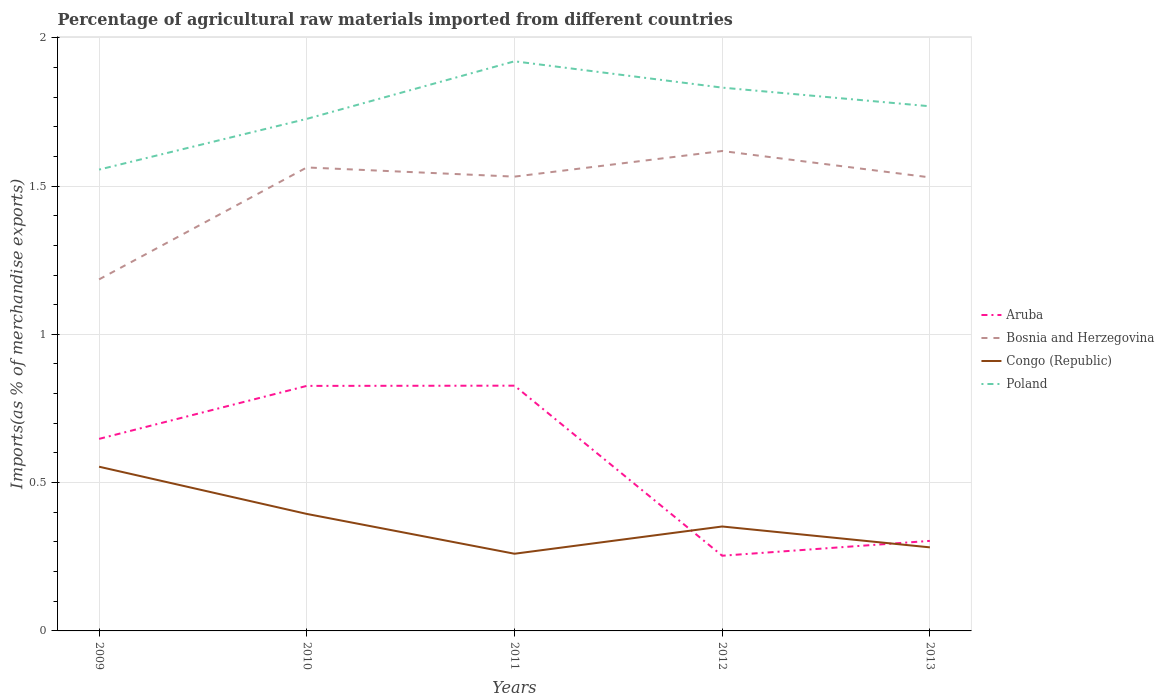How many different coloured lines are there?
Offer a very short reply. 4. Does the line corresponding to Aruba intersect with the line corresponding to Bosnia and Herzegovina?
Your answer should be very brief. No. Is the number of lines equal to the number of legend labels?
Your answer should be very brief. Yes. Across all years, what is the maximum percentage of imports to different countries in Poland?
Provide a short and direct response. 1.56. What is the total percentage of imports to different countries in Poland in the graph?
Your response must be concise. 0.15. What is the difference between the highest and the second highest percentage of imports to different countries in Bosnia and Herzegovina?
Make the answer very short. 0.43. How many lines are there?
Your response must be concise. 4. How many years are there in the graph?
Ensure brevity in your answer.  5. Are the values on the major ticks of Y-axis written in scientific E-notation?
Your answer should be compact. No. Does the graph contain grids?
Give a very brief answer. Yes. How are the legend labels stacked?
Make the answer very short. Vertical. What is the title of the graph?
Your answer should be very brief. Percentage of agricultural raw materials imported from different countries. Does "Arab World" appear as one of the legend labels in the graph?
Your response must be concise. No. What is the label or title of the Y-axis?
Ensure brevity in your answer.  Imports(as % of merchandise exports). What is the Imports(as % of merchandise exports) of Aruba in 2009?
Offer a very short reply. 0.65. What is the Imports(as % of merchandise exports) in Bosnia and Herzegovina in 2009?
Offer a very short reply. 1.19. What is the Imports(as % of merchandise exports) in Congo (Republic) in 2009?
Your answer should be compact. 0.55. What is the Imports(as % of merchandise exports) of Poland in 2009?
Your answer should be compact. 1.56. What is the Imports(as % of merchandise exports) of Aruba in 2010?
Your answer should be very brief. 0.83. What is the Imports(as % of merchandise exports) of Bosnia and Herzegovina in 2010?
Your response must be concise. 1.56. What is the Imports(as % of merchandise exports) in Congo (Republic) in 2010?
Make the answer very short. 0.39. What is the Imports(as % of merchandise exports) in Poland in 2010?
Give a very brief answer. 1.73. What is the Imports(as % of merchandise exports) of Aruba in 2011?
Your response must be concise. 0.83. What is the Imports(as % of merchandise exports) in Bosnia and Herzegovina in 2011?
Offer a very short reply. 1.53. What is the Imports(as % of merchandise exports) in Congo (Republic) in 2011?
Offer a very short reply. 0.26. What is the Imports(as % of merchandise exports) of Poland in 2011?
Offer a terse response. 1.92. What is the Imports(as % of merchandise exports) in Aruba in 2012?
Offer a very short reply. 0.25. What is the Imports(as % of merchandise exports) in Bosnia and Herzegovina in 2012?
Provide a short and direct response. 1.62. What is the Imports(as % of merchandise exports) of Congo (Republic) in 2012?
Provide a short and direct response. 0.35. What is the Imports(as % of merchandise exports) of Poland in 2012?
Give a very brief answer. 1.83. What is the Imports(as % of merchandise exports) of Aruba in 2013?
Provide a succinct answer. 0.3. What is the Imports(as % of merchandise exports) in Bosnia and Herzegovina in 2013?
Your response must be concise. 1.53. What is the Imports(as % of merchandise exports) of Congo (Republic) in 2013?
Your answer should be very brief. 0.28. What is the Imports(as % of merchandise exports) of Poland in 2013?
Ensure brevity in your answer.  1.77. Across all years, what is the maximum Imports(as % of merchandise exports) of Aruba?
Make the answer very short. 0.83. Across all years, what is the maximum Imports(as % of merchandise exports) in Bosnia and Herzegovina?
Your answer should be very brief. 1.62. Across all years, what is the maximum Imports(as % of merchandise exports) in Congo (Republic)?
Offer a terse response. 0.55. Across all years, what is the maximum Imports(as % of merchandise exports) in Poland?
Offer a very short reply. 1.92. Across all years, what is the minimum Imports(as % of merchandise exports) of Aruba?
Provide a succinct answer. 0.25. Across all years, what is the minimum Imports(as % of merchandise exports) of Bosnia and Herzegovina?
Provide a succinct answer. 1.19. Across all years, what is the minimum Imports(as % of merchandise exports) in Congo (Republic)?
Provide a short and direct response. 0.26. Across all years, what is the minimum Imports(as % of merchandise exports) of Poland?
Keep it short and to the point. 1.56. What is the total Imports(as % of merchandise exports) of Aruba in the graph?
Ensure brevity in your answer.  2.86. What is the total Imports(as % of merchandise exports) in Bosnia and Herzegovina in the graph?
Make the answer very short. 7.43. What is the total Imports(as % of merchandise exports) of Congo (Republic) in the graph?
Offer a terse response. 1.84. What is the total Imports(as % of merchandise exports) of Poland in the graph?
Offer a very short reply. 8.8. What is the difference between the Imports(as % of merchandise exports) of Aruba in 2009 and that in 2010?
Your answer should be very brief. -0.18. What is the difference between the Imports(as % of merchandise exports) in Bosnia and Herzegovina in 2009 and that in 2010?
Ensure brevity in your answer.  -0.38. What is the difference between the Imports(as % of merchandise exports) of Congo (Republic) in 2009 and that in 2010?
Your response must be concise. 0.16. What is the difference between the Imports(as % of merchandise exports) of Poland in 2009 and that in 2010?
Make the answer very short. -0.17. What is the difference between the Imports(as % of merchandise exports) of Aruba in 2009 and that in 2011?
Keep it short and to the point. -0.18. What is the difference between the Imports(as % of merchandise exports) in Bosnia and Herzegovina in 2009 and that in 2011?
Offer a very short reply. -0.35. What is the difference between the Imports(as % of merchandise exports) of Congo (Republic) in 2009 and that in 2011?
Make the answer very short. 0.29. What is the difference between the Imports(as % of merchandise exports) of Poland in 2009 and that in 2011?
Ensure brevity in your answer.  -0.37. What is the difference between the Imports(as % of merchandise exports) of Aruba in 2009 and that in 2012?
Offer a terse response. 0.39. What is the difference between the Imports(as % of merchandise exports) of Bosnia and Herzegovina in 2009 and that in 2012?
Your response must be concise. -0.43. What is the difference between the Imports(as % of merchandise exports) in Congo (Republic) in 2009 and that in 2012?
Give a very brief answer. 0.2. What is the difference between the Imports(as % of merchandise exports) in Poland in 2009 and that in 2012?
Offer a very short reply. -0.28. What is the difference between the Imports(as % of merchandise exports) in Aruba in 2009 and that in 2013?
Your answer should be very brief. 0.34. What is the difference between the Imports(as % of merchandise exports) in Bosnia and Herzegovina in 2009 and that in 2013?
Keep it short and to the point. -0.34. What is the difference between the Imports(as % of merchandise exports) of Congo (Republic) in 2009 and that in 2013?
Provide a succinct answer. 0.27. What is the difference between the Imports(as % of merchandise exports) in Poland in 2009 and that in 2013?
Offer a terse response. -0.21. What is the difference between the Imports(as % of merchandise exports) in Aruba in 2010 and that in 2011?
Give a very brief answer. -0. What is the difference between the Imports(as % of merchandise exports) in Bosnia and Herzegovina in 2010 and that in 2011?
Provide a succinct answer. 0.03. What is the difference between the Imports(as % of merchandise exports) in Congo (Republic) in 2010 and that in 2011?
Offer a terse response. 0.13. What is the difference between the Imports(as % of merchandise exports) of Poland in 2010 and that in 2011?
Keep it short and to the point. -0.19. What is the difference between the Imports(as % of merchandise exports) of Aruba in 2010 and that in 2012?
Provide a succinct answer. 0.57. What is the difference between the Imports(as % of merchandise exports) of Bosnia and Herzegovina in 2010 and that in 2012?
Ensure brevity in your answer.  -0.06. What is the difference between the Imports(as % of merchandise exports) in Congo (Republic) in 2010 and that in 2012?
Your answer should be compact. 0.04. What is the difference between the Imports(as % of merchandise exports) of Poland in 2010 and that in 2012?
Your answer should be very brief. -0.11. What is the difference between the Imports(as % of merchandise exports) in Aruba in 2010 and that in 2013?
Offer a very short reply. 0.52. What is the difference between the Imports(as % of merchandise exports) in Bosnia and Herzegovina in 2010 and that in 2013?
Keep it short and to the point. 0.03. What is the difference between the Imports(as % of merchandise exports) in Congo (Republic) in 2010 and that in 2013?
Your answer should be very brief. 0.11. What is the difference between the Imports(as % of merchandise exports) in Poland in 2010 and that in 2013?
Your answer should be compact. -0.04. What is the difference between the Imports(as % of merchandise exports) in Aruba in 2011 and that in 2012?
Give a very brief answer. 0.57. What is the difference between the Imports(as % of merchandise exports) in Bosnia and Herzegovina in 2011 and that in 2012?
Offer a terse response. -0.09. What is the difference between the Imports(as % of merchandise exports) of Congo (Republic) in 2011 and that in 2012?
Your answer should be very brief. -0.09. What is the difference between the Imports(as % of merchandise exports) in Poland in 2011 and that in 2012?
Your answer should be compact. 0.09. What is the difference between the Imports(as % of merchandise exports) in Aruba in 2011 and that in 2013?
Make the answer very short. 0.52. What is the difference between the Imports(as % of merchandise exports) in Bosnia and Herzegovina in 2011 and that in 2013?
Provide a succinct answer. 0. What is the difference between the Imports(as % of merchandise exports) in Congo (Republic) in 2011 and that in 2013?
Provide a short and direct response. -0.02. What is the difference between the Imports(as % of merchandise exports) in Poland in 2011 and that in 2013?
Offer a terse response. 0.15. What is the difference between the Imports(as % of merchandise exports) in Aruba in 2012 and that in 2013?
Keep it short and to the point. -0.05. What is the difference between the Imports(as % of merchandise exports) of Bosnia and Herzegovina in 2012 and that in 2013?
Ensure brevity in your answer.  0.09. What is the difference between the Imports(as % of merchandise exports) in Congo (Republic) in 2012 and that in 2013?
Give a very brief answer. 0.07. What is the difference between the Imports(as % of merchandise exports) in Poland in 2012 and that in 2013?
Provide a succinct answer. 0.06. What is the difference between the Imports(as % of merchandise exports) of Aruba in 2009 and the Imports(as % of merchandise exports) of Bosnia and Herzegovina in 2010?
Offer a very short reply. -0.92. What is the difference between the Imports(as % of merchandise exports) in Aruba in 2009 and the Imports(as % of merchandise exports) in Congo (Republic) in 2010?
Provide a succinct answer. 0.25. What is the difference between the Imports(as % of merchandise exports) of Aruba in 2009 and the Imports(as % of merchandise exports) of Poland in 2010?
Offer a terse response. -1.08. What is the difference between the Imports(as % of merchandise exports) of Bosnia and Herzegovina in 2009 and the Imports(as % of merchandise exports) of Congo (Republic) in 2010?
Provide a short and direct response. 0.79. What is the difference between the Imports(as % of merchandise exports) in Bosnia and Herzegovina in 2009 and the Imports(as % of merchandise exports) in Poland in 2010?
Offer a terse response. -0.54. What is the difference between the Imports(as % of merchandise exports) of Congo (Republic) in 2009 and the Imports(as % of merchandise exports) of Poland in 2010?
Your answer should be compact. -1.17. What is the difference between the Imports(as % of merchandise exports) in Aruba in 2009 and the Imports(as % of merchandise exports) in Bosnia and Herzegovina in 2011?
Provide a succinct answer. -0.88. What is the difference between the Imports(as % of merchandise exports) in Aruba in 2009 and the Imports(as % of merchandise exports) in Congo (Republic) in 2011?
Provide a short and direct response. 0.39. What is the difference between the Imports(as % of merchandise exports) of Aruba in 2009 and the Imports(as % of merchandise exports) of Poland in 2011?
Keep it short and to the point. -1.27. What is the difference between the Imports(as % of merchandise exports) of Bosnia and Herzegovina in 2009 and the Imports(as % of merchandise exports) of Congo (Republic) in 2011?
Offer a terse response. 0.93. What is the difference between the Imports(as % of merchandise exports) in Bosnia and Herzegovina in 2009 and the Imports(as % of merchandise exports) in Poland in 2011?
Keep it short and to the point. -0.74. What is the difference between the Imports(as % of merchandise exports) in Congo (Republic) in 2009 and the Imports(as % of merchandise exports) in Poland in 2011?
Provide a short and direct response. -1.37. What is the difference between the Imports(as % of merchandise exports) of Aruba in 2009 and the Imports(as % of merchandise exports) of Bosnia and Herzegovina in 2012?
Offer a terse response. -0.97. What is the difference between the Imports(as % of merchandise exports) of Aruba in 2009 and the Imports(as % of merchandise exports) of Congo (Republic) in 2012?
Offer a terse response. 0.3. What is the difference between the Imports(as % of merchandise exports) in Aruba in 2009 and the Imports(as % of merchandise exports) in Poland in 2012?
Your answer should be compact. -1.18. What is the difference between the Imports(as % of merchandise exports) of Bosnia and Herzegovina in 2009 and the Imports(as % of merchandise exports) of Congo (Republic) in 2012?
Make the answer very short. 0.83. What is the difference between the Imports(as % of merchandise exports) of Bosnia and Herzegovina in 2009 and the Imports(as % of merchandise exports) of Poland in 2012?
Make the answer very short. -0.65. What is the difference between the Imports(as % of merchandise exports) in Congo (Republic) in 2009 and the Imports(as % of merchandise exports) in Poland in 2012?
Offer a very short reply. -1.28. What is the difference between the Imports(as % of merchandise exports) of Aruba in 2009 and the Imports(as % of merchandise exports) of Bosnia and Herzegovina in 2013?
Your answer should be compact. -0.88. What is the difference between the Imports(as % of merchandise exports) of Aruba in 2009 and the Imports(as % of merchandise exports) of Congo (Republic) in 2013?
Provide a succinct answer. 0.37. What is the difference between the Imports(as % of merchandise exports) in Aruba in 2009 and the Imports(as % of merchandise exports) in Poland in 2013?
Keep it short and to the point. -1.12. What is the difference between the Imports(as % of merchandise exports) of Bosnia and Herzegovina in 2009 and the Imports(as % of merchandise exports) of Congo (Republic) in 2013?
Your answer should be very brief. 0.9. What is the difference between the Imports(as % of merchandise exports) in Bosnia and Herzegovina in 2009 and the Imports(as % of merchandise exports) in Poland in 2013?
Your response must be concise. -0.58. What is the difference between the Imports(as % of merchandise exports) of Congo (Republic) in 2009 and the Imports(as % of merchandise exports) of Poland in 2013?
Keep it short and to the point. -1.22. What is the difference between the Imports(as % of merchandise exports) in Aruba in 2010 and the Imports(as % of merchandise exports) in Bosnia and Herzegovina in 2011?
Your answer should be compact. -0.71. What is the difference between the Imports(as % of merchandise exports) in Aruba in 2010 and the Imports(as % of merchandise exports) in Congo (Republic) in 2011?
Your answer should be very brief. 0.57. What is the difference between the Imports(as % of merchandise exports) of Aruba in 2010 and the Imports(as % of merchandise exports) of Poland in 2011?
Your answer should be compact. -1.09. What is the difference between the Imports(as % of merchandise exports) in Bosnia and Herzegovina in 2010 and the Imports(as % of merchandise exports) in Congo (Republic) in 2011?
Make the answer very short. 1.3. What is the difference between the Imports(as % of merchandise exports) in Bosnia and Herzegovina in 2010 and the Imports(as % of merchandise exports) in Poland in 2011?
Your response must be concise. -0.36. What is the difference between the Imports(as % of merchandise exports) in Congo (Republic) in 2010 and the Imports(as % of merchandise exports) in Poland in 2011?
Provide a short and direct response. -1.53. What is the difference between the Imports(as % of merchandise exports) of Aruba in 2010 and the Imports(as % of merchandise exports) of Bosnia and Herzegovina in 2012?
Offer a very short reply. -0.79. What is the difference between the Imports(as % of merchandise exports) in Aruba in 2010 and the Imports(as % of merchandise exports) in Congo (Republic) in 2012?
Your response must be concise. 0.47. What is the difference between the Imports(as % of merchandise exports) in Aruba in 2010 and the Imports(as % of merchandise exports) in Poland in 2012?
Your answer should be very brief. -1.01. What is the difference between the Imports(as % of merchandise exports) of Bosnia and Herzegovina in 2010 and the Imports(as % of merchandise exports) of Congo (Republic) in 2012?
Provide a short and direct response. 1.21. What is the difference between the Imports(as % of merchandise exports) of Bosnia and Herzegovina in 2010 and the Imports(as % of merchandise exports) of Poland in 2012?
Make the answer very short. -0.27. What is the difference between the Imports(as % of merchandise exports) in Congo (Republic) in 2010 and the Imports(as % of merchandise exports) in Poland in 2012?
Give a very brief answer. -1.44. What is the difference between the Imports(as % of merchandise exports) in Aruba in 2010 and the Imports(as % of merchandise exports) in Bosnia and Herzegovina in 2013?
Make the answer very short. -0.7. What is the difference between the Imports(as % of merchandise exports) in Aruba in 2010 and the Imports(as % of merchandise exports) in Congo (Republic) in 2013?
Keep it short and to the point. 0.54. What is the difference between the Imports(as % of merchandise exports) in Aruba in 2010 and the Imports(as % of merchandise exports) in Poland in 2013?
Your answer should be very brief. -0.94. What is the difference between the Imports(as % of merchandise exports) in Bosnia and Herzegovina in 2010 and the Imports(as % of merchandise exports) in Congo (Republic) in 2013?
Make the answer very short. 1.28. What is the difference between the Imports(as % of merchandise exports) in Bosnia and Herzegovina in 2010 and the Imports(as % of merchandise exports) in Poland in 2013?
Give a very brief answer. -0.21. What is the difference between the Imports(as % of merchandise exports) of Congo (Republic) in 2010 and the Imports(as % of merchandise exports) of Poland in 2013?
Your answer should be compact. -1.37. What is the difference between the Imports(as % of merchandise exports) of Aruba in 2011 and the Imports(as % of merchandise exports) of Bosnia and Herzegovina in 2012?
Your answer should be compact. -0.79. What is the difference between the Imports(as % of merchandise exports) of Aruba in 2011 and the Imports(as % of merchandise exports) of Congo (Republic) in 2012?
Make the answer very short. 0.47. What is the difference between the Imports(as % of merchandise exports) in Aruba in 2011 and the Imports(as % of merchandise exports) in Poland in 2012?
Give a very brief answer. -1. What is the difference between the Imports(as % of merchandise exports) of Bosnia and Herzegovina in 2011 and the Imports(as % of merchandise exports) of Congo (Republic) in 2012?
Your response must be concise. 1.18. What is the difference between the Imports(as % of merchandise exports) of Bosnia and Herzegovina in 2011 and the Imports(as % of merchandise exports) of Poland in 2012?
Offer a terse response. -0.3. What is the difference between the Imports(as % of merchandise exports) in Congo (Republic) in 2011 and the Imports(as % of merchandise exports) in Poland in 2012?
Give a very brief answer. -1.57. What is the difference between the Imports(as % of merchandise exports) in Aruba in 2011 and the Imports(as % of merchandise exports) in Bosnia and Herzegovina in 2013?
Offer a very short reply. -0.7. What is the difference between the Imports(as % of merchandise exports) in Aruba in 2011 and the Imports(as % of merchandise exports) in Congo (Republic) in 2013?
Your answer should be compact. 0.55. What is the difference between the Imports(as % of merchandise exports) in Aruba in 2011 and the Imports(as % of merchandise exports) in Poland in 2013?
Offer a terse response. -0.94. What is the difference between the Imports(as % of merchandise exports) in Bosnia and Herzegovina in 2011 and the Imports(as % of merchandise exports) in Poland in 2013?
Provide a succinct answer. -0.24. What is the difference between the Imports(as % of merchandise exports) of Congo (Republic) in 2011 and the Imports(as % of merchandise exports) of Poland in 2013?
Offer a terse response. -1.51. What is the difference between the Imports(as % of merchandise exports) in Aruba in 2012 and the Imports(as % of merchandise exports) in Bosnia and Herzegovina in 2013?
Provide a succinct answer. -1.28. What is the difference between the Imports(as % of merchandise exports) of Aruba in 2012 and the Imports(as % of merchandise exports) of Congo (Republic) in 2013?
Make the answer very short. -0.03. What is the difference between the Imports(as % of merchandise exports) in Aruba in 2012 and the Imports(as % of merchandise exports) in Poland in 2013?
Offer a very short reply. -1.52. What is the difference between the Imports(as % of merchandise exports) of Bosnia and Herzegovina in 2012 and the Imports(as % of merchandise exports) of Congo (Republic) in 2013?
Your response must be concise. 1.34. What is the difference between the Imports(as % of merchandise exports) of Bosnia and Herzegovina in 2012 and the Imports(as % of merchandise exports) of Poland in 2013?
Ensure brevity in your answer.  -0.15. What is the difference between the Imports(as % of merchandise exports) of Congo (Republic) in 2012 and the Imports(as % of merchandise exports) of Poland in 2013?
Your response must be concise. -1.42. What is the average Imports(as % of merchandise exports) in Aruba per year?
Keep it short and to the point. 0.57. What is the average Imports(as % of merchandise exports) in Bosnia and Herzegovina per year?
Provide a short and direct response. 1.49. What is the average Imports(as % of merchandise exports) in Congo (Republic) per year?
Your answer should be compact. 0.37. What is the average Imports(as % of merchandise exports) of Poland per year?
Your answer should be very brief. 1.76. In the year 2009, what is the difference between the Imports(as % of merchandise exports) of Aruba and Imports(as % of merchandise exports) of Bosnia and Herzegovina?
Keep it short and to the point. -0.54. In the year 2009, what is the difference between the Imports(as % of merchandise exports) in Aruba and Imports(as % of merchandise exports) in Congo (Republic)?
Ensure brevity in your answer.  0.09. In the year 2009, what is the difference between the Imports(as % of merchandise exports) of Aruba and Imports(as % of merchandise exports) of Poland?
Your answer should be compact. -0.91. In the year 2009, what is the difference between the Imports(as % of merchandise exports) in Bosnia and Herzegovina and Imports(as % of merchandise exports) in Congo (Republic)?
Keep it short and to the point. 0.63. In the year 2009, what is the difference between the Imports(as % of merchandise exports) in Bosnia and Herzegovina and Imports(as % of merchandise exports) in Poland?
Your response must be concise. -0.37. In the year 2009, what is the difference between the Imports(as % of merchandise exports) of Congo (Republic) and Imports(as % of merchandise exports) of Poland?
Offer a very short reply. -1. In the year 2010, what is the difference between the Imports(as % of merchandise exports) of Aruba and Imports(as % of merchandise exports) of Bosnia and Herzegovina?
Offer a very short reply. -0.74. In the year 2010, what is the difference between the Imports(as % of merchandise exports) in Aruba and Imports(as % of merchandise exports) in Congo (Republic)?
Give a very brief answer. 0.43. In the year 2010, what is the difference between the Imports(as % of merchandise exports) in Aruba and Imports(as % of merchandise exports) in Poland?
Offer a very short reply. -0.9. In the year 2010, what is the difference between the Imports(as % of merchandise exports) of Bosnia and Herzegovina and Imports(as % of merchandise exports) of Congo (Republic)?
Give a very brief answer. 1.17. In the year 2010, what is the difference between the Imports(as % of merchandise exports) in Bosnia and Herzegovina and Imports(as % of merchandise exports) in Poland?
Your response must be concise. -0.16. In the year 2010, what is the difference between the Imports(as % of merchandise exports) of Congo (Republic) and Imports(as % of merchandise exports) of Poland?
Ensure brevity in your answer.  -1.33. In the year 2011, what is the difference between the Imports(as % of merchandise exports) of Aruba and Imports(as % of merchandise exports) of Bosnia and Herzegovina?
Keep it short and to the point. -0.7. In the year 2011, what is the difference between the Imports(as % of merchandise exports) in Aruba and Imports(as % of merchandise exports) in Congo (Republic)?
Ensure brevity in your answer.  0.57. In the year 2011, what is the difference between the Imports(as % of merchandise exports) in Aruba and Imports(as % of merchandise exports) in Poland?
Make the answer very short. -1.09. In the year 2011, what is the difference between the Imports(as % of merchandise exports) of Bosnia and Herzegovina and Imports(as % of merchandise exports) of Congo (Republic)?
Provide a short and direct response. 1.27. In the year 2011, what is the difference between the Imports(as % of merchandise exports) in Bosnia and Herzegovina and Imports(as % of merchandise exports) in Poland?
Provide a short and direct response. -0.39. In the year 2011, what is the difference between the Imports(as % of merchandise exports) of Congo (Republic) and Imports(as % of merchandise exports) of Poland?
Your response must be concise. -1.66. In the year 2012, what is the difference between the Imports(as % of merchandise exports) of Aruba and Imports(as % of merchandise exports) of Bosnia and Herzegovina?
Provide a succinct answer. -1.36. In the year 2012, what is the difference between the Imports(as % of merchandise exports) of Aruba and Imports(as % of merchandise exports) of Congo (Republic)?
Make the answer very short. -0.1. In the year 2012, what is the difference between the Imports(as % of merchandise exports) in Aruba and Imports(as % of merchandise exports) in Poland?
Your answer should be very brief. -1.58. In the year 2012, what is the difference between the Imports(as % of merchandise exports) of Bosnia and Herzegovina and Imports(as % of merchandise exports) of Congo (Republic)?
Offer a very short reply. 1.27. In the year 2012, what is the difference between the Imports(as % of merchandise exports) in Bosnia and Herzegovina and Imports(as % of merchandise exports) in Poland?
Offer a very short reply. -0.21. In the year 2012, what is the difference between the Imports(as % of merchandise exports) of Congo (Republic) and Imports(as % of merchandise exports) of Poland?
Offer a terse response. -1.48. In the year 2013, what is the difference between the Imports(as % of merchandise exports) of Aruba and Imports(as % of merchandise exports) of Bosnia and Herzegovina?
Offer a terse response. -1.23. In the year 2013, what is the difference between the Imports(as % of merchandise exports) of Aruba and Imports(as % of merchandise exports) of Congo (Republic)?
Offer a very short reply. 0.02. In the year 2013, what is the difference between the Imports(as % of merchandise exports) of Aruba and Imports(as % of merchandise exports) of Poland?
Your answer should be compact. -1.47. In the year 2013, what is the difference between the Imports(as % of merchandise exports) in Bosnia and Herzegovina and Imports(as % of merchandise exports) in Congo (Republic)?
Ensure brevity in your answer.  1.25. In the year 2013, what is the difference between the Imports(as % of merchandise exports) in Bosnia and Herzegovina and Imports(as % of merchandise exports) in Poland?
Provide a succinct answer. -0.24. In the year 2013, what is the difference between the Imports(as % of merchandise exports) in Congo (Republic) and Imports(as % of merchandise exports) in Poland?
Provide a short and direct response. -1.49. What is the ratio of the Imports(as % of merchandise exports) in Aruba in 2009 to that in 2010?
Your response must be concise. 0.78. What is the ratio of the Imports(as % of merchandise exports) of Bosnia and Herzegovina in 2009 to that in 2010?
Offer a terse response. 0.76. What is the ratio of the Imports(as % of merchandise exports) of Congo (Republic) in 2009 to that in 2010?
Keep it short and to the point. 1.4. What is the ratio of the Imports(as % of merchandise exports) in Poland in 2009 to that in 2010?
Your answer should be compact. 0.9. What is the ratio of the Imports(as % of merchandise exports) in Aruba in 2009 to that in 2011?
Give a very brief answer. 0.78. What is the ratio of the Imports(as % of merchandise exports) of Bosnia and Herzegovina in 2009 to that in 2011?
Your answer should be compact. 0.77. What is the ratio of the Imports(as % of merchandise exports) of Congo (Republic) in 2009 to that in 2011?
Make the answer very short. 2.13. What is the ratio of the Imports(as % of merchandise exports) of Poland in 2009 to that in 2011?
Give a very brief answer. 0.81. What is the ratio of the Imports(as % of merchandise exports) in Aruba in 2009 to that in 2012?
Offer a terse response. 2.55. What is the ratio of the Imports(as % of merchandise exports) of Bosnia and Herzegovina in 2009 to that in 2012?
Ensure brevity in your answer.  0.73. What is the ratio of the Imports(as % of merchandise exports) in Congo (Republic) in 2009 to that in 2012?
Provide a short and direct response. 1.57. What is the ratio of the Imports(as % of merchandise exports) of Poland in 2009 to that in 2012?
Provide a succinct answer. 0.85. What is the ratio of the Imports(as % of merchandise exports) in Aruba in 2009 to that in 2013?
Keep it short and to the point. 2.13. What is the ratio of the Imports(as % of merchandise exports) of Bosnia and Herzegovina in 2009 to that in 2013?
Offer a terse response. 0.78. What is the ratio of the Imports(as % of merchandise exports) in Congo (Republic) in 2009 to that in 2013?
Make the answer very short. 1.97. What is the ratio of the Imports(as % of merchandise exports) of Poland in 2009 to that in 2013?
Keep it short and to the point. 0.88. What is the ratio of the Imports(as % of merchandise exports) in Aruba in 2010 to that in 2011?
Offer a very short reply. 1. What is the ratio of the Imports(as % of merchandise exports) in Bosnia and Herzegovina in 2010 to that in 2011?
Keep it short and to the point. 1.02. What is the ratio of the Imports(as % of merchandise exports) of Congo (Republic) in 2010 to that in 2011?
Give a very brief answer. 1.52. What is the ratio of the Imports(as % of merchandise exports) of Poland in 2010 to that in 2011?
Make the answer very short. 0.9. What is the ratio of the Imports(as % of merchandise exports) in Aruba in 2010 to that in 2012?
Offer a terse response. 3.26. What is the ratio of the Imports(as % of merchandise exports) in Bosnia and Herzegovina in 2010 to that in 2012?
Keep it short and to the point. 0.97. What is the ratio of the Imports(as % of merchandise exports) of Congo (Republic) in 2010 to that in 2012?
Keep it short and to the point. 1.12. What is the ratio of the Imports(as % of merchandise exports) in Poland in 2010 to that in 2012?
Provide a succinct answer. 0.94. What is the ratio of the Imports(as % of merchandise exports) in Aruba in 2010 to that in 2013?
Ensure brevity in your answer.  2.72. What is the ratio of the Imports(as % of merchandise exports) of Bosnia and Herzegovina in 2010 to that in 2013?
Give a very brief answer. 1.02. What is the ratio of the Imports(as % of merchandise exports) of Congo (Republic) in 2010 to that in 2013?
Your answer should be compact. 1.4. What is the ratio of the Imports(as % of merchandise exports) of Poland in 2010 to that in 2013?
Your response must be concise. 0.98. What is the ratio of the Imports(as % of merchandise exports) of Aruba in 2011 to that in 2012?
Ensure brevity in your answer.  3.26. What is the ratio of the Imports(as % of merchandise exports) of Bosnia and Herzegovina in 2011 to that in 2012?
Ensure brevity in your answer.  0.95. What is the ratio of the Imports(as % of merchandise exports) in Congo (Republic) in 2011 to that in 2012?
Provide a short and direct response. 0.74. What is the ratio of the Imports(as % of merchandise exports) in Poland in 2011 to that in 2012?
Provide a succinct answer. 1.05. What is the ratio of the Imports(as % of merchandise exports) of Aruba in 2011 to that in 2013?
Your response must be concise. 2.72. What is the ratio of the Imports(as % of merchandise exports) of Bosnia and Herzegovina in 2011 to that in 2013?
Your response must be concise. 1. What is the ratio of the Imports(as % of merchandise exports) in Congo (Republic) in 2011 to that in 2013?
Offer a very short reply. 0.92. What is the ratio of the Imports(as % of merchandise exports) of Poland in 2011 to that in 2013?
Your response must be concise. 1.09. What is the ratio of the Imports(as % of merchandise exports) of Aruba in 2012 to that in 2013?
Offer a terse response. 0.84. What is the ratio of the Imports(as % of merchandise exports) of Bosnia and Herzegovina in 2012 to that in 2013?
Your answer should be compact. 1.06. What is the ratio of the Imports(as % of merchandise exports) in Congo (Republic) in 2012 to that in 2013?
Offer a very short reply. 1.25. What is the ratio of the Imports(as % of merchandise exports) of Poland in 2012 to that in 2013?
Provide a succinct answer. 1.04. What is the difference between the highest and the second highest Imports(as % of merchandise exports) of Aruba?
Your answer should be very brief. 0. What is the difference between the highest and the second highest Imports(as % of merchandise exports) of Bosnia and Herzegovina?
Your answer should be compact. 0.06. What is the difference between the highest and the second highest Imports(as % of merchandise exports) of Congo (Republic)?
Make the answer very short. 0.16. What is the difference between the highest and the second highest Imports(as % of merchandise exports) of Poland?
Your response must be concise. 0.09. What is the difference between the highest and the lowest Imports(as % of merchandise exports) in Aruba?
Offer a very short reply. 0.57. What is the difference between the highest and the lowest Imports(as % of merchandise exports) of Bosnia and Herzegovina?
Your answer should be compact. 0.43. What is the difference between the highest and the lowest Imports(as % of merchandise exports) in Congo (Republic)?
Keep it short and to the point. 0.29. What is the difference between the highest and the lowest Imports(as % of merchandise exports) of Poland?
Provide a short and direct response. 0.37. 